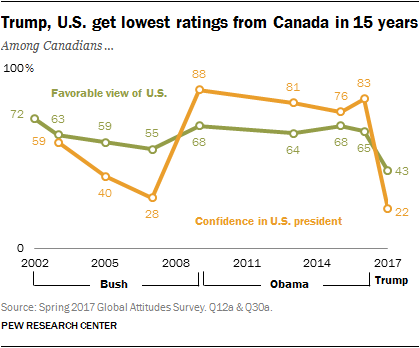Outline some significant characteristics in this image. The orange graph has a ratio of approximately 0.167361111... between its highest and lowest values. The lowest value on the orange graph is 22. 